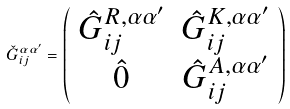<formula> <loc_0><loc_0><loc_500><loc_500>\check { G } _ { i j } ^ { \alpha \alpha ^ { \prime } } = \left ( \begin{array} { c c } \hat { G } _ { i j } ^ { R , \alpha \alpha ^ { \prime } } & \hat { G } _ { i j } ^ { K , \alpha \alpha ^ { \prime } } \\ \hat { 0 } & \hat { G } _ { i j } ^ { A , \alpha \alpha ^ { \prime } } \end{array} \right )</formula> 